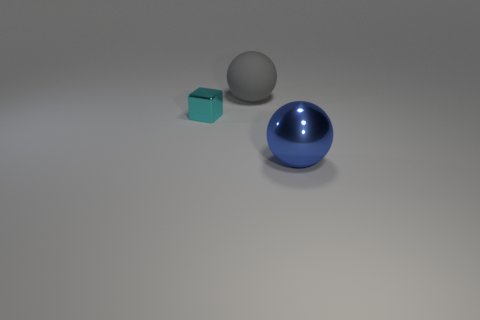Add 2 large gray balls. How many objects exist? 5 Subtract all cubes. How many objects are left? 2 Add 3 big gray things. How many big gray things are left? 4 Add 1 big blue rubber cylinders. How many big blue rubber cylinders exist? 1 Subtract 0 yellow cylinders. How many objects are left? 3 Subtract all cyan rubber cylinders. Subtract all large objects. How many objects are left? 1 